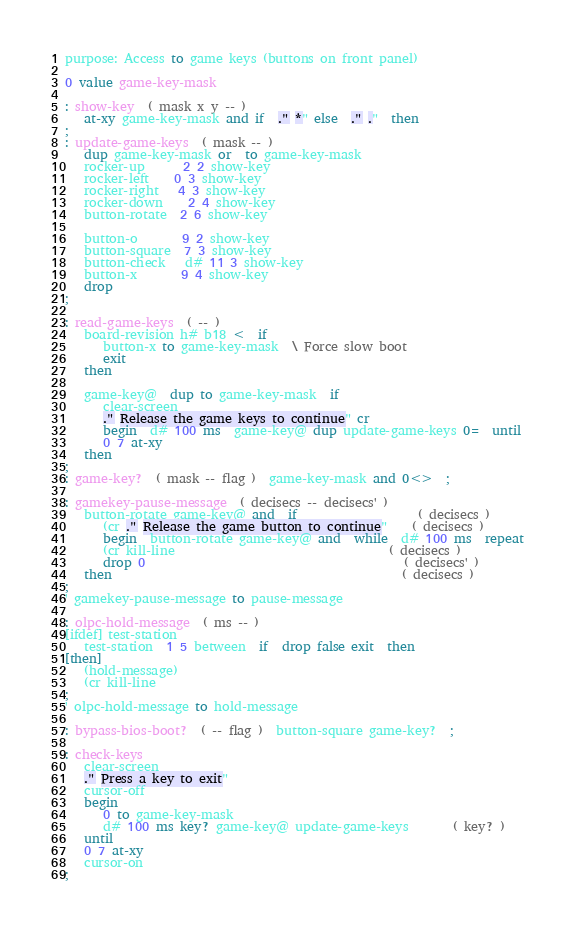Convert code to text. <code><loc_0><loc_0><loc_500><loc_500><_Forth_>purpose: Access to game keys (buttons on front panel)

0 value game-key-mask

: show-key  ( mask x y -- )
   at-xy game-key-mask and if  ." *" else  ." ."  then
;
: update-game-keys  ( mask -- )
   dup game-key-mask or  to game-key-mask
   rocker-up      2 2 show-key
   rocker-left    0 3 show-key
   rocker-right   4 3 show-key
   rocker-down    2 4 show-key
   button-rotate  2 6 show-key

   button-o       9 2 show-key
   button-square  7 3 show-key
   button-check   d# 11 3 show-key
   button-x       9 4 show-key
   drop
;

: read-game-keys  ( -- )
   board-revision h# b18 <  if
      button-x to game-key-mask  \ Force slow boot
      exit
   then

   game-key@  dup to game-key-mask  if
      clear-screen
      ." Release the game keys to continue" cr
      begin  d# 100 ms  game-key@ dup update-game-keys 0=  until
      0 7 at-xy
   then
;
: game-key?  ( mask -- flag )  game-key-mask and 0<>  ;

: gamekey-pause-message  ( decisecs -- decisecs' )
   button-rotate game-key@ and  if                   ( decisecs )
      (cr ." Release the game button to continue"    ( decisecs )
      begin  button-rotate game-key@ and  while  d# 100 ms  repeat
      (cr kill-line                                  ( decisecs )
      drop 0                                         ( decisecs' )
   then                                              ( decisecs )
;
' gamekey-pause-message to pause-message

: olpc-hold-message  ( ms -- )
[ifdef] test-station
   test-station  1 5 between  if  drop false exit  then
[then]
   (hold-message)
   (cr kill-line
;
' olpc-hold-message to hold-message

: bypass-bios-boot?  ( -- flag )  button-square game-key?  ;

: check-keys
   clear-screen
   ." Press a key to exit"
   cursor-off
   begin
      0 to game-key-mask  
      d# 100 ms key? game-key@ update-game-keys       ( key? ) 
   until
   0 7 at-xy
   cursor-on
;
</code> 